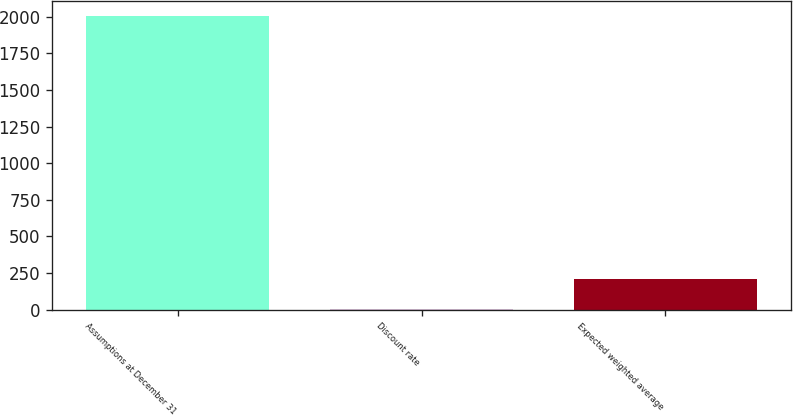<chart> <loc_0><loc_0><loc_500><loc_500><bar_chart><fcel>Assumptions at December 31<fcel>Discount rate<fcel>Expected weighted average<nl><fcel>2007<fcel>6.33<fcel>206.4<nl></chart> 